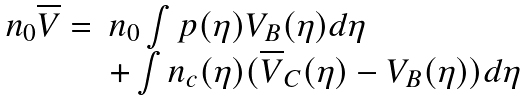<formula> <loc_0><loc_0><loc_500><loc_500>\begin{array} { l l } n _ { 0 } \overline { V } = & n _ { 0 } \int p ( \eta ) V _ { B } ( \eta ) d \eta \\ & + \int n _ { c } ( \eta ) ( \overline { V } _ { C } ( \eta ) - V _ { B } ( \eta ) ) d \eta \end{array}</formula> 